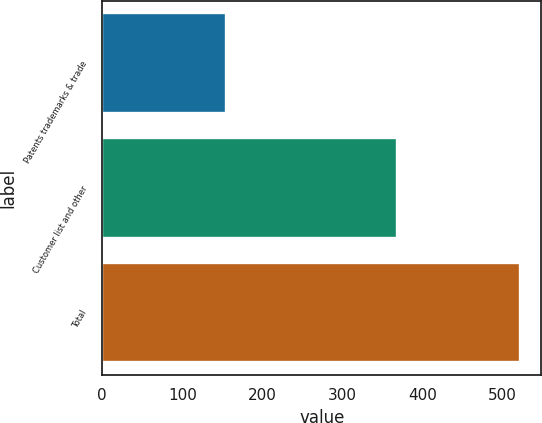Convert chart to OTSL. <chart><loc_0><loc_0><loc_500><loc_500><bar_chart><fcel>Patents trademarks & trade<fcel>Customer list and other<fcel>Total<nl><fcel>154<fcel>368<fcel>522<nl></chart> 